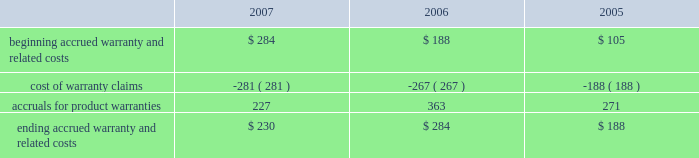Notes to consolidated financial statements ( continued ) note 8 2014commitments and contingencies ( continued ) the table reconciles changes in the company 2019s accrued warranties and related costs ( in millions ) : .
The company generally does not indemnify end-users of its operating system and application software against legal claims that the software infringes third-party intellectual property rights .
Other agreements entered into by the company sometimes include indemnification provisions under which the company could be subject to costs and/or damages in the event of an infringement claim against the company or an indemnified third-party .
However , the company has not been required to make any significant payments resulting from such an infringement claim asserted against itself or an indemnified third-party and , in the opinion of management , does not have a potential liability related to unresolved infringement claims subject to indemnification that would have a material adverse effect on its financial condition or operating results .
Therefore , the company did not record a liability for infringement costs as of either september 29 , 2007 or september 30 , 2006 .
Concentrations in the available sources of supply of materials and product certain key components including , but not limited to , microprocessors , enclosures , certain lcds , certain optical drives , and application-specific integrated circuits ( 2018 2018asics 2019 2019 ) are currently obtained by the company from single or limited sources which subjects the company to supply and pricing risks .
Many of these and other key components that are available from multiple sources including , but not limited to , nand flash memory , dram memory , and certain lcds , are at times subject to industry-wide shortages and significant commodity pricing fluctuations .
In addition , the company has entered into certain agreements for the supply of critical components at favorable pricing , and there is no guarantee that the company will be able to extend or renew these agreements when they expire .
Therefore , the company remains subject to significant risks of supply shortages and/or price increases that can adversely affect gross margins and operating margins .
In addition , the company uses some components that are not common to the rest of the global personal computer , consumer electronics and mobile communication industries , and new products introduced by the company often utilize custom components obtained from only one source until the company has evaluated whether there is a need for and subsequently qualifies additional suppliers .
If the supply of a key single-sourced component to the company were to be delayed or curtailed , or in the event a key manufacturing vendor delays shipments of completed products to the company , the company 2019s ability to ship related products in desired quantities and in a timely manner could be adversely affected .
The company 2019s business and financial performance could also be adversely affected depending on the time required to obtain sufficient quantities from the original source , or to identify and obtain sufficient quantities from an alternative source .
Continued availability of these components may be affected if producers were to decide to concentrate on the production of common components instead of components customized to meet the company 2019s requirements .
Finally , significant portions of the company 2019s cpus , ipods , iphones , logic boards , and other assembled products are now manufactured by outsourcing partners , primarily in various parts of asia .
A significant concentration of this outsourced manufacturing is currently performed by only a few of the company 2019s outsourcing partners , often in single locations .
Certain of these outsourcing partners are the sole-sourced supplier of components and manufacturing outsourcing for many of the company 2019s key products , including but not limited to , assembly .
What was the percentage change in accrued warranties and related costs from 2006 to 2007? 
Computations: ((230 - 284) / 284)
Answer: -0.19014. 